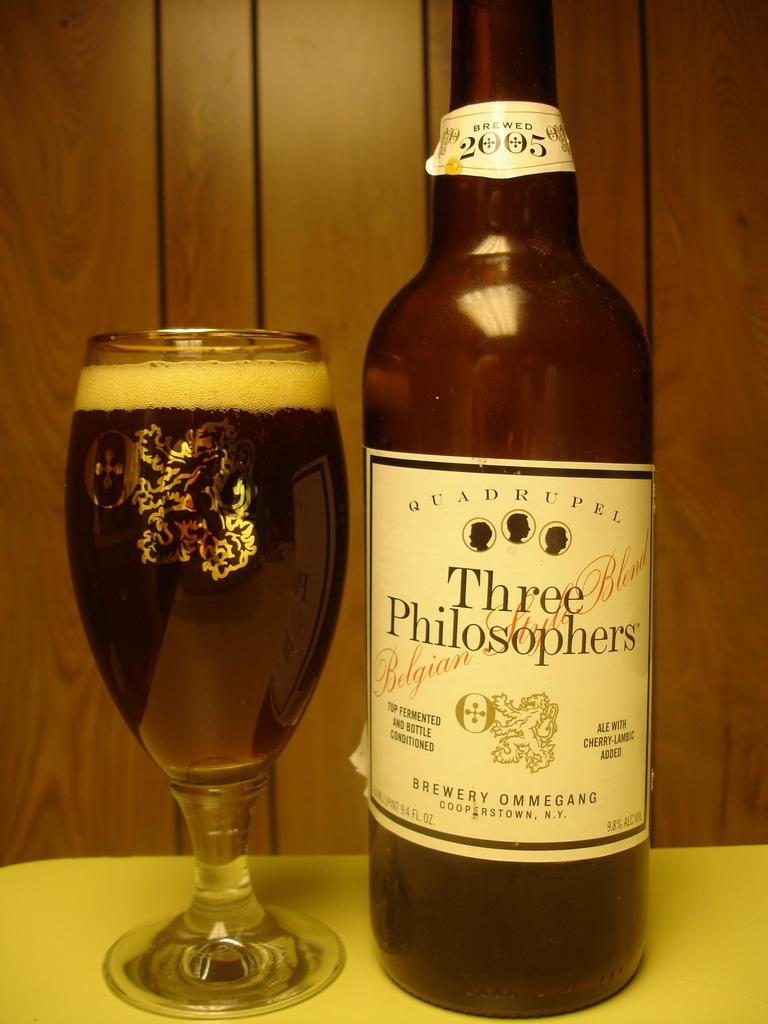What kind if beer is this?
Provide a succinct answer. Three philosophers. What is the name of brewery that manufactures this beer?
Ensure brevity in your answer.  Three philosophers. 